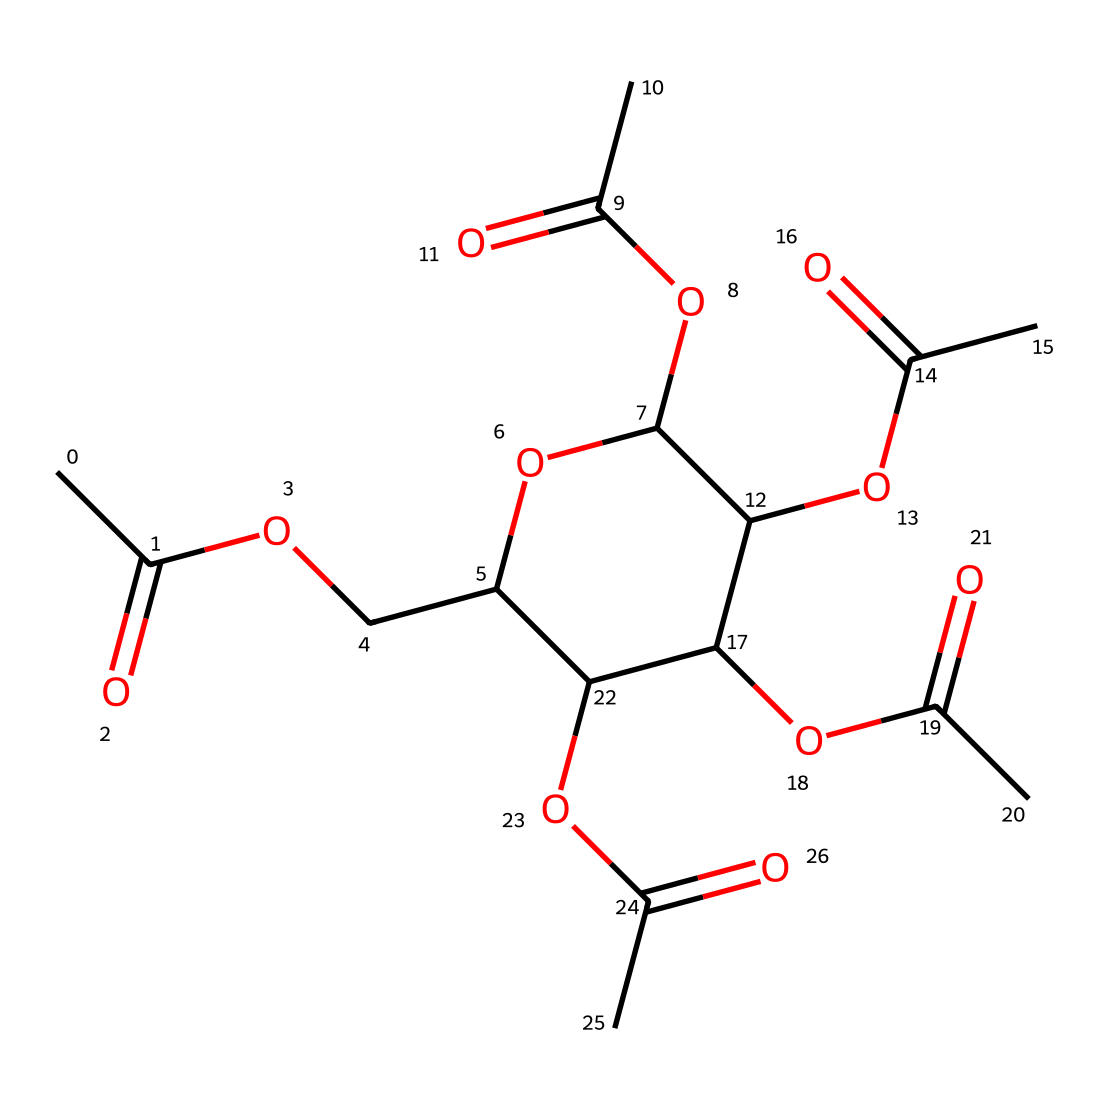What is the main functional group present in cellulose acetate? The structure shows multiple acetyl groups, which support the conclusion that the main functional group is the acetyl group (-COCH3).
Answer: acetyl group How many carbon atoms are in this cellulose acetate molecule? Counting the carbon atoms from the SMILES representation reveals a total of 12 carbon atoms throughout the structure, including those in the acetyl groups and the backbone.
Answer: 12 Does this compound qualify as a polymer? The structure consists of repeating units of acetate linked together, which is characteristic of a polymeric substance, confirming that cellulose acetate is indeed a polymer.
Answer: yes What are the primary types of bonds present in cellulose acetate? Analyzing the structure, it contains primarily single covalent bonds (C-C, C-O) and some carbonyl double bonds (C=O), which are typical in esters like cellulose acetate.
Answer: covalent bonds How many acetyl groups are present in the chemical structure? Reviewing the structure reveals there are 5 acetyl groups (each represented by the -C(=O)CH3) repeating in the chemical representation, indicating their presence counts.
Answer: 5 What property does cellulose acetate exhibit as a non-electrolyte? As a non-electrolyte, cellulose acetate does not dissociate into ions in solution, which is evident because the structure lacks conductive ionic configurations.
Answer: does not conduct electricity What is the significance of the degree of substitution in cellulose acetate? The degree of substitution determines the number of hydroxyl groups replaced by acetyl groups, influencing properties like solubility and film-forming capabilities of cellulose acetate.
Answer: influences solubility 